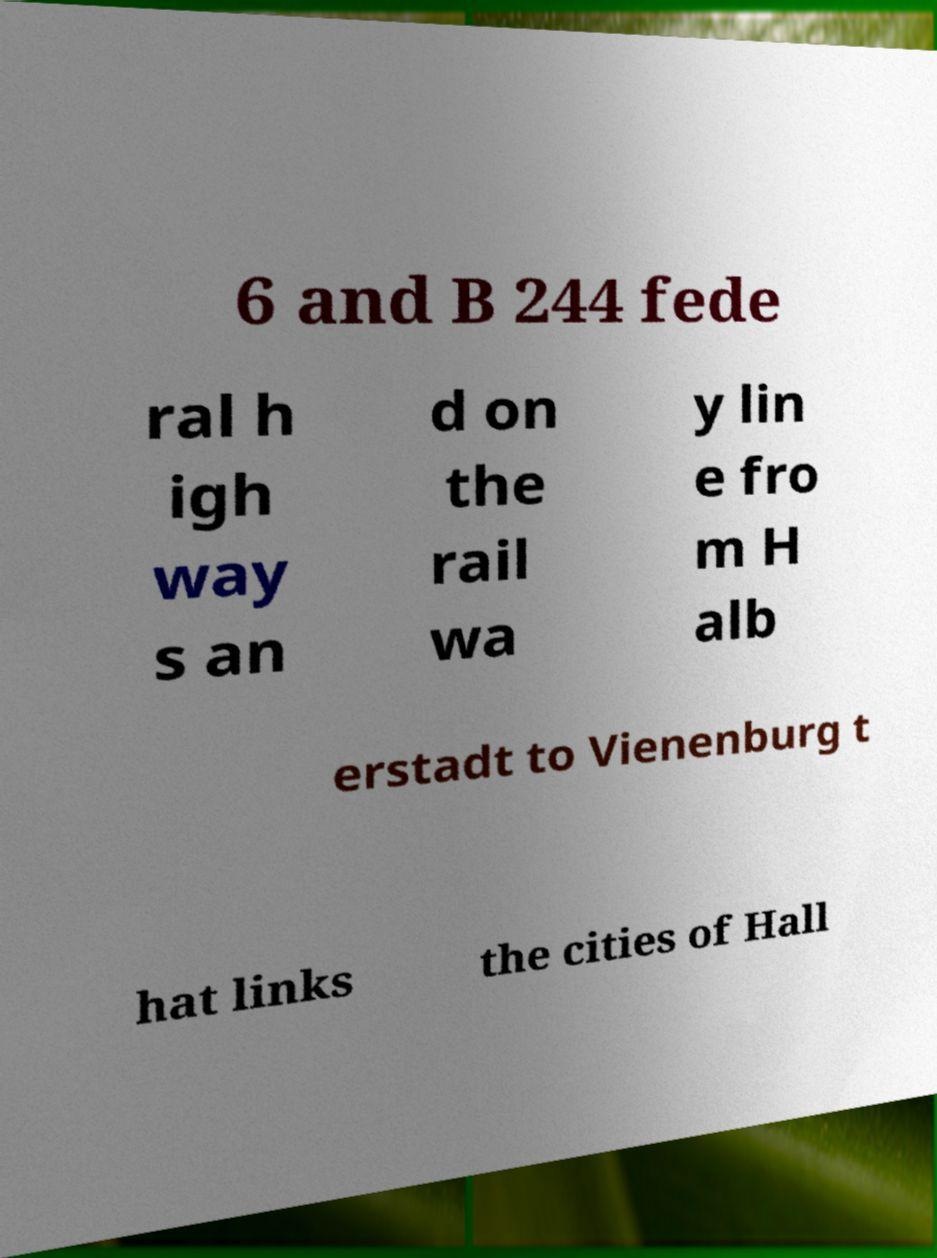Could you assist in decoding the text presented in this image and type it out clearly? 6 and B 244 fede ral h igh way s an d on the rail wa y lin e fro m H alb erstadt to Vienenburg t hat links the cities of Hall 